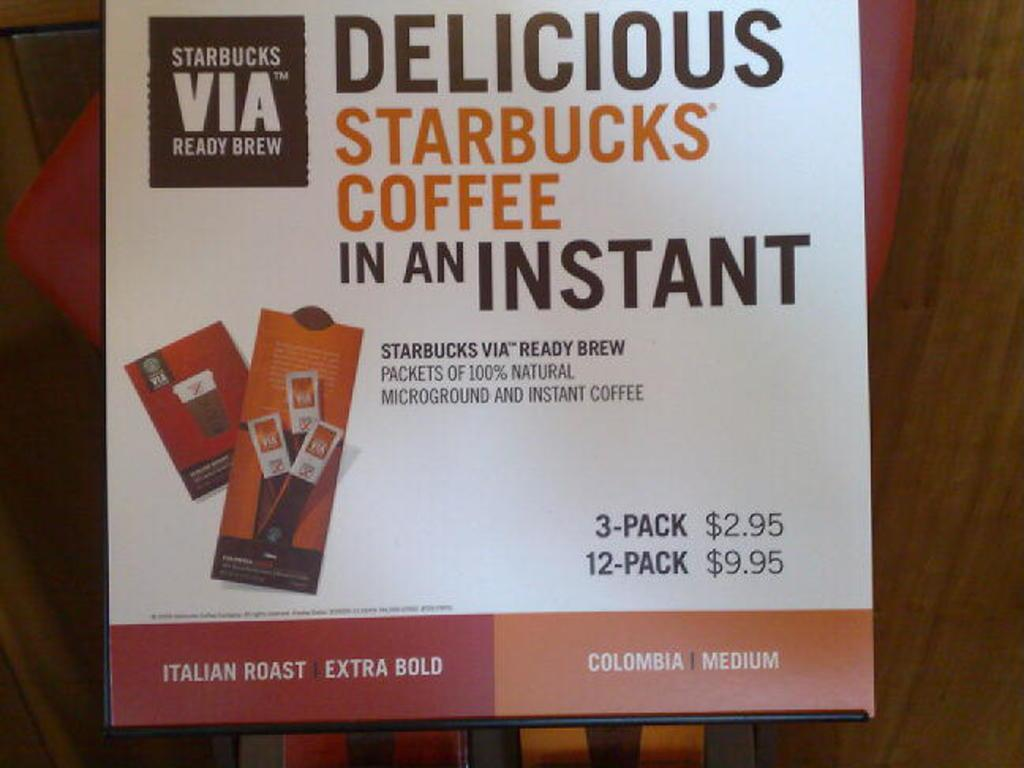<image>
Describe the image concisely. A sign that offers Star Bucks Instant Coffee for 2.95 a  pack. 